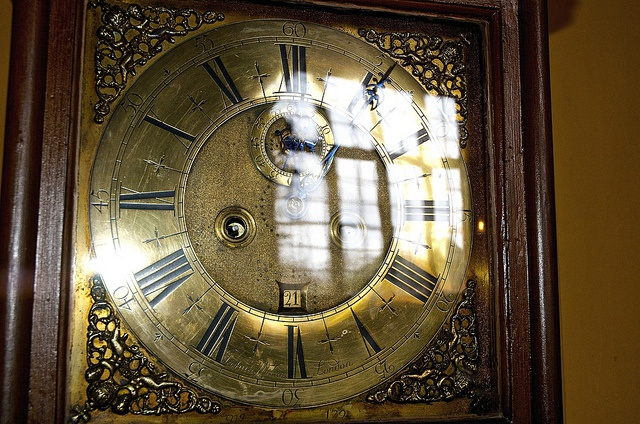Describe the objects in this image and their specific colors. I can see a clock in maroon, olive, white, black, and tan tones in this image. 